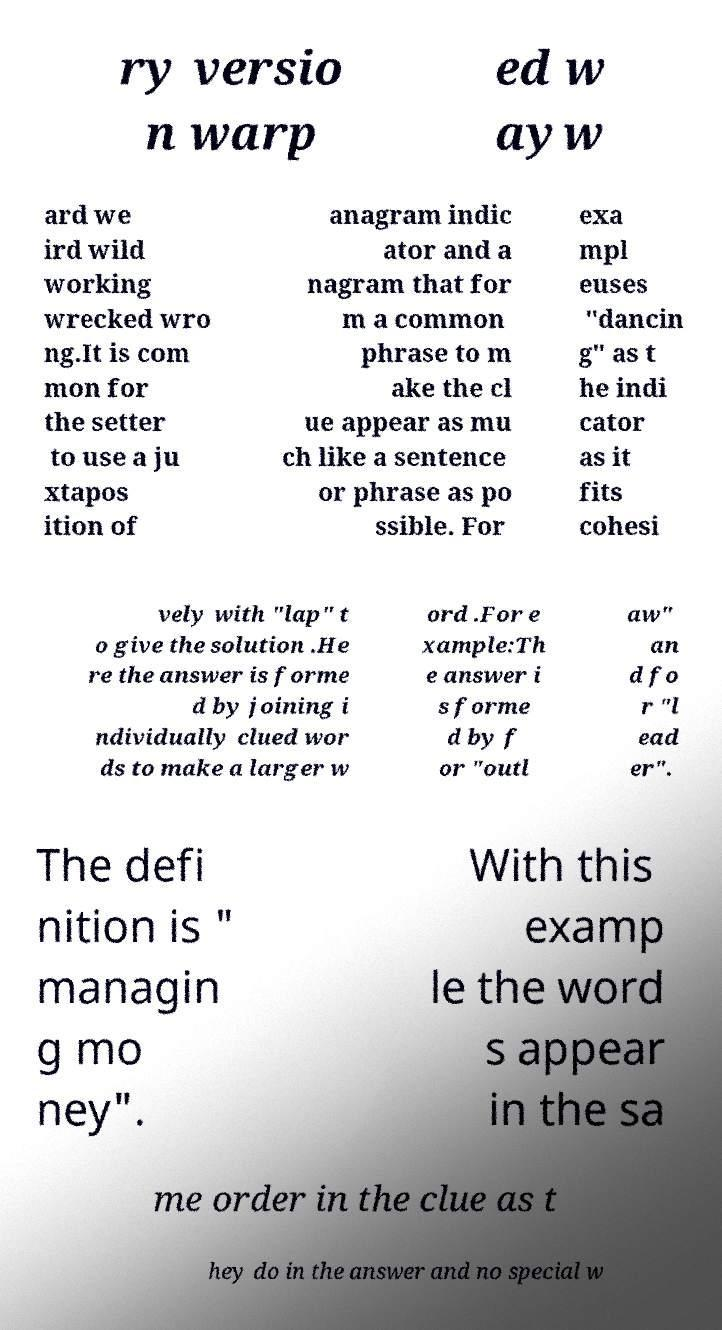Please identify and transcribe the text found in this image. ry versio n warp ed w ayw ard we ird wild working wrecked wro ng.It is com mon for the setter to use a ju xtapos ition of anagram indic ator and a nagram that for m a common phrase to m ake the cl ue appear as mu ch like a sentence or phrase as po ssible. For exa mpl euses "dancin g" as t he indi cator as it fits cohesi vely with "lap" t o give the solution .He re the answer is forme d by joining i ndividually clued wor ds to make a larger w ord .For e xample:Th e answer i s forme d by f or "outl aw" an d fo r "l ead er". The defi nition is " managin g mo ney". With this examp le the word s appear in the sa me order in the clue as t hey do in the answer and no special w 